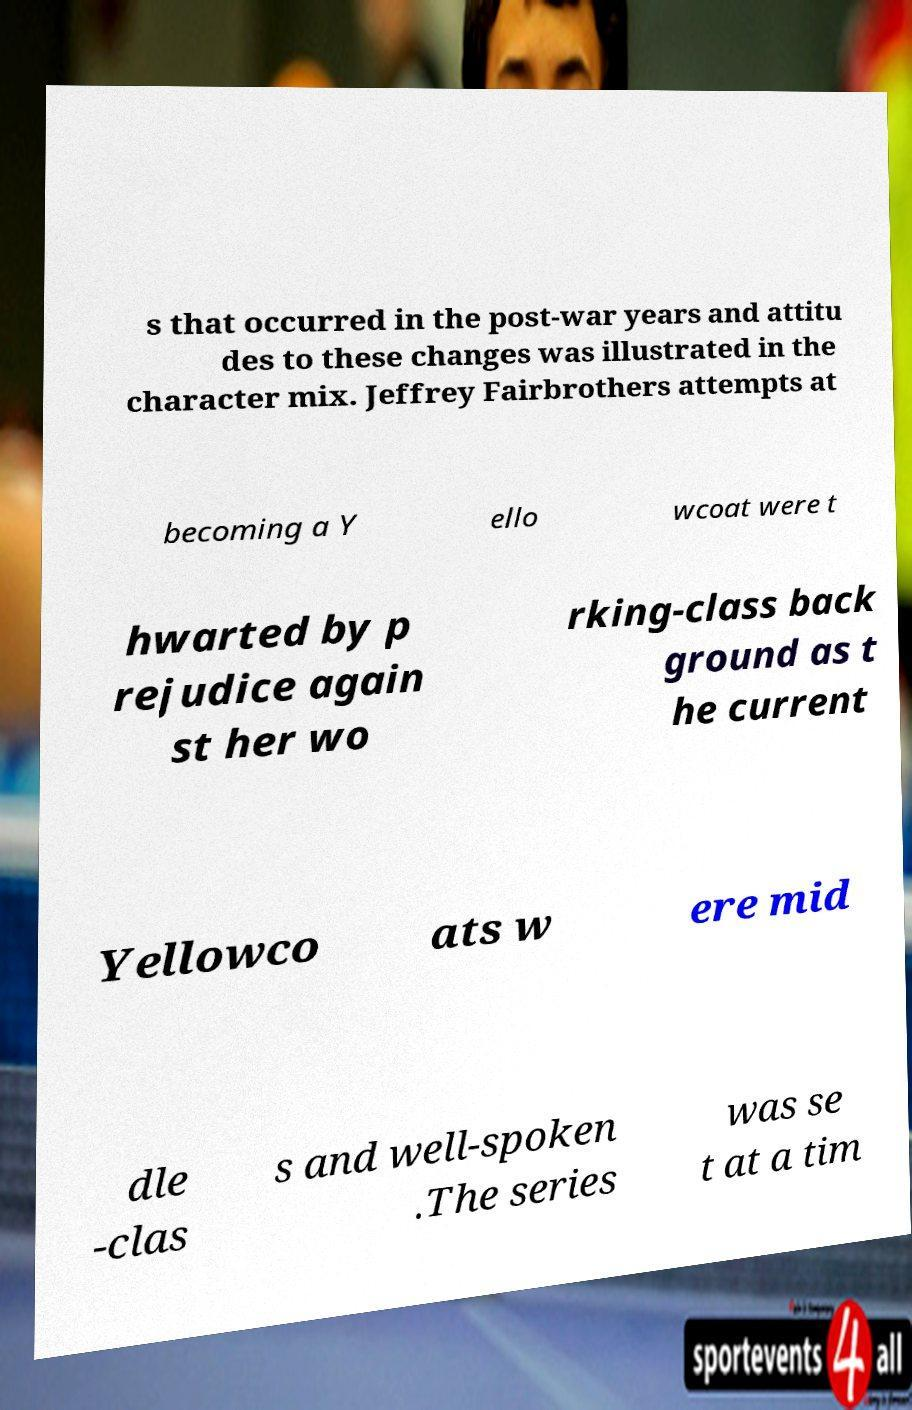What messages or text are displayed in this image? I need them in a readable, typed format. s that occurred in the post-war years and attitu des to these changes was illustrated in the character mix. Jeffrey Fairbrothers attempts at becoming a Y ello wcoat were t hwarted by p rejudice again st her wo rking-class back ground as t he current Yellowco ats w ere mid dle -clas s and well-spoken .The series was se t at a tim 